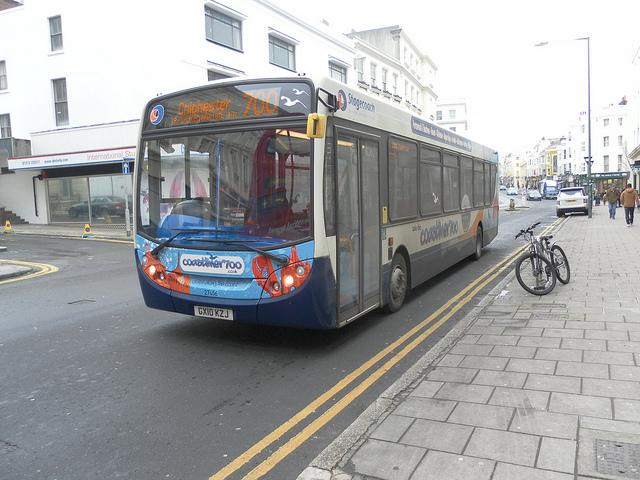Which vehicle has violated the law? bicycle 